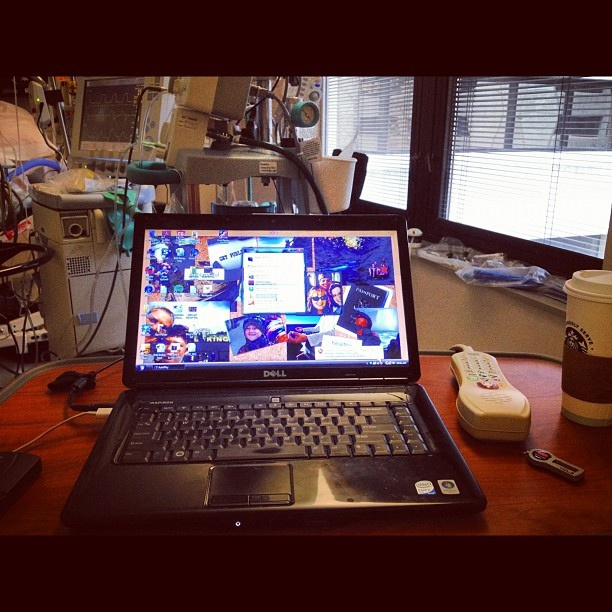Describe the objects in this image and their specific colors. I can see laptop in black, white, maroon, and brown tones, cup in black, maroon, brown, and gray tones, tv in black, maroon, brown, and gray tones, and remote in black, tan, and maroon tones in this image. 